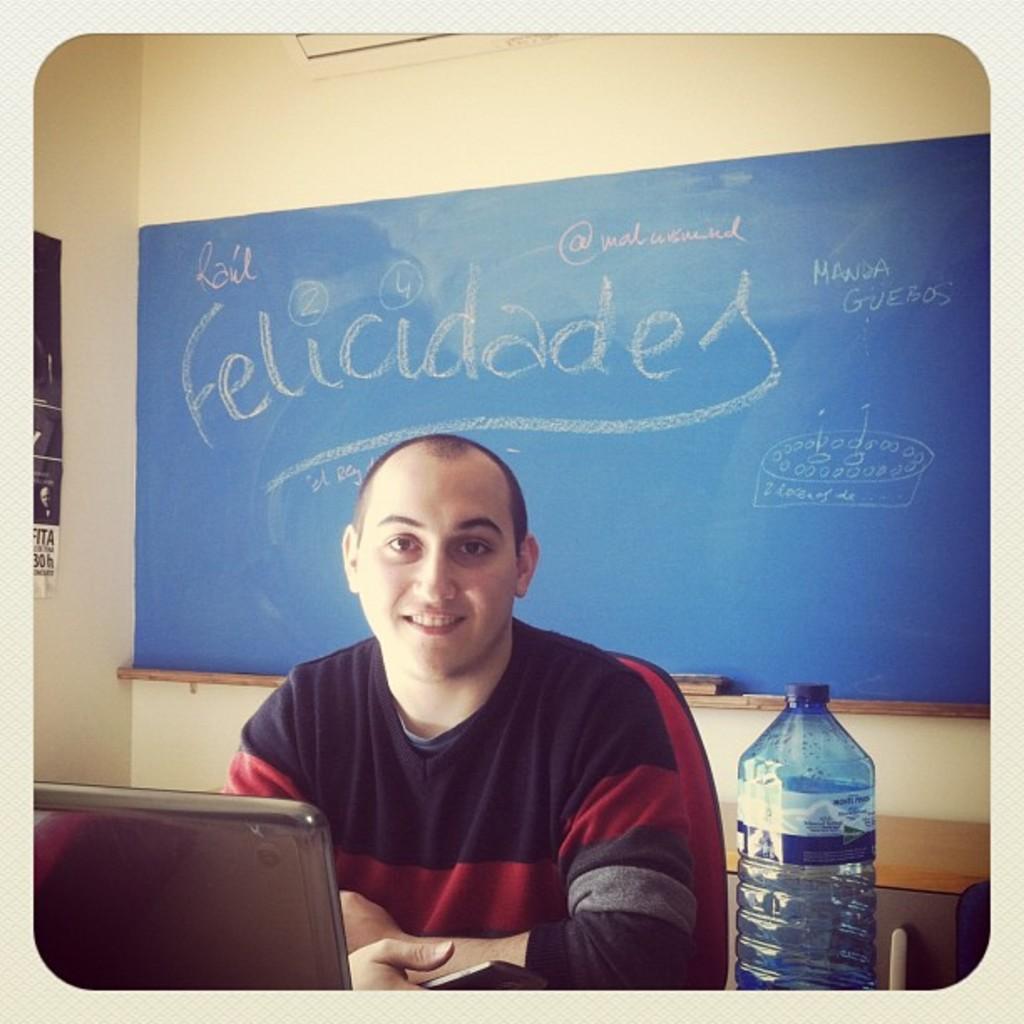In one or two sentences, can you explain what this image depicts? A man is sitting on the chair. In front of him there is a laptop and bottle. Behind him there is a board. On the board something is written and there is a wall. 